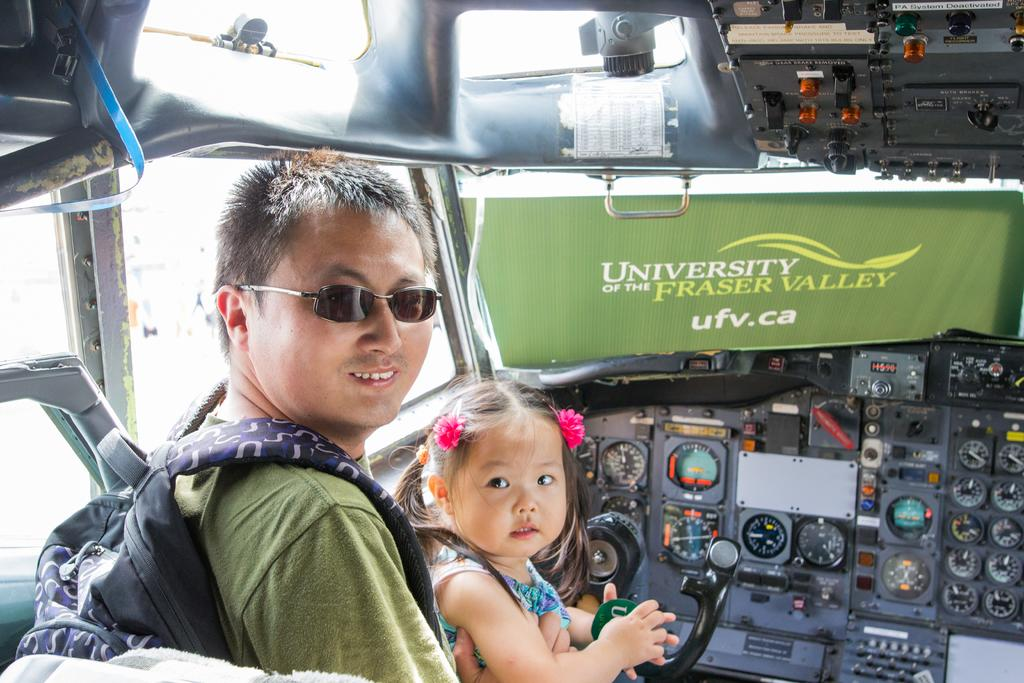Who are the people in the image? There is a man and a girl sitting in the image. What is the man wearing? The man is wearing a bag, a t-shirt, and shades. What can be seen in the background of the image? There are meters and buttons in the image. What other objects are present in the image? There are other objects in the image, but their specific details are not mentioned in the provided facts. What type of salt is being used to rake the ground in the image? There is no salt or rake present in the image. Can you describe the girl's reaction to the man taking a bite of the buttons in the image? There is no indication in the image that the man is taking a bite of the buttons, nor is there any information about the girl's reaction. 